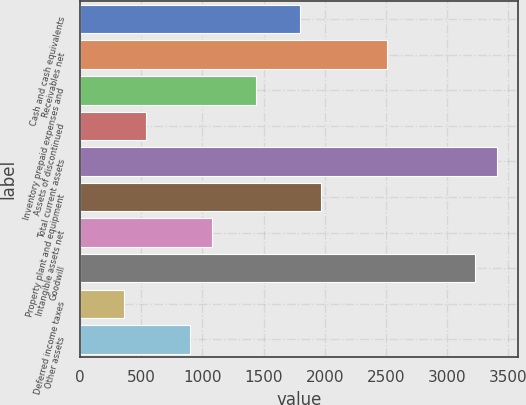Convert chart. <chart><loc_0><loc_0><loc_500><loc_500><bar_chart><fcel>Cash and cash equivalents<fcel>Receivables net<fcel>Inventory prepaid expenses and<fcel>Assets of discontinued<fcel>Total current assets<fcel>Property plant and equipment<fcel>Intangible assets net<fcel>Goodwill<fcel>Deferred income taxes<fcel>Other assets<nl><fcel>1794<fcel>2509.6<fcel>1436.2<fcel>541.7<fcel>3404.1<fcel>1972.9<fcel>1078.4<fcel>3225.2<fcel>362.8<fcel>899.5<nl></chart> 